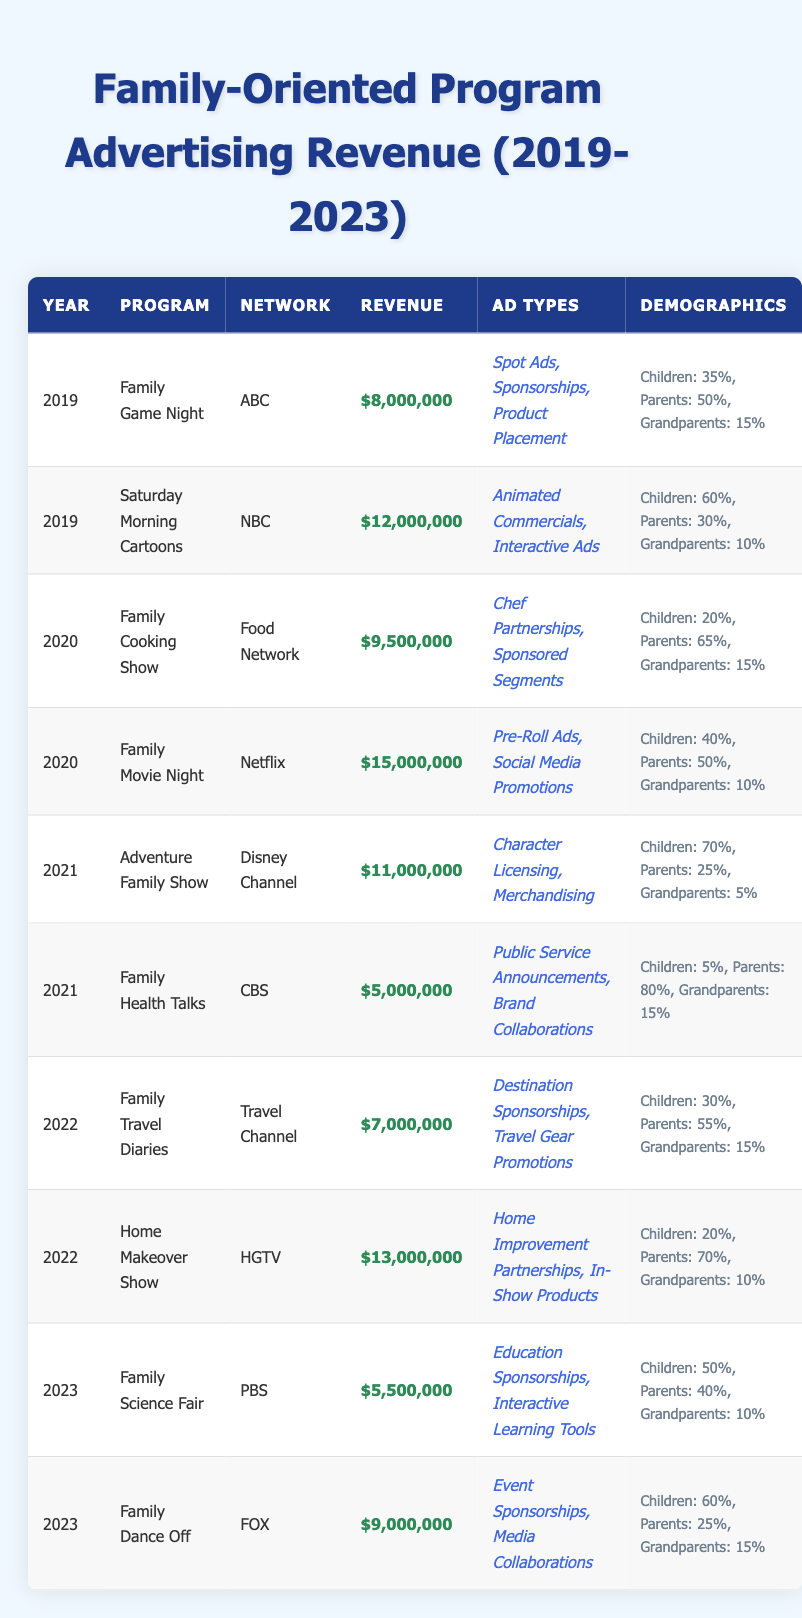What was the total advertising revenue for family-oriented programs in 2020? In 2020, the two programs listed are "Family Cooking Show" with $9,500,000 and "Family Movie Night" with $15,000,000. Summing these amounts gives $9,500,000 + $15,000,000 = $24,500,000.
Answer: $24,500,000 Which program generated the highest advertising revenue in 2021? In 2021, the two programs are "Adventure Family Show" with $11,000,000 and "Family Health Talks" with $5,000,000. The higher amount is $11,000,000 from "Adventure Family Show."
Answer: Adventure Family Show What percentage of the audience for "Family Science Fair" in 2023 were children? The demographics for "Family Science Fair" in 2023 state that 50% of the audience were children.
Answer: 50% How does the advertising revenue of "Home Makeover Show" in 2022 compare to that of "Family Dance Off" in 2023? "Home Makeover Show" earned $13,000,000 in 2022, while "Family Dance Off" earned $9,000,000 in 2023. Comparing these, $13,000,000 is greater than $9,000,000.
Answer: Home Makeover Show had higher revenue What is the total revenue across all years for programs with "Sponsorships" in their ad types? The programs with "Sponsorships" are "Family Game Night" ($8,000,000), "Family Cooking Show" ($9,500,000), "Family Science Fair" ($5,500,000), and "Family Dance Off" ($9,000,000). Summing these revenues gives $8,000,000 + $9,500,000 + $5,500,000 + $9,000,000 = $32,000,000.
Answer: $32,000,000 What percentage of the audience for "Adventure Family Show" in 2021 were grandparents? The demographics for "Adventure Family Show" indicate that 5% of the audience were grandparents.
Answer: 5% Was "Saturday Morning Cartoons" the most profitable program in 2019? In 2019, "Saturday Morning Cartoons" earned $12,000,000, while "Family Game Night" earned $8,000,000. Since $12,000,000 is greater than $8,000,000, "Saturday Morning Cartoons" was the most profitable program that year.
Answer: Yes What is the average revenue for family-oriented programs across all the years listed? The total revenue summed over all entries is ($8,000,000 + $12,000,000 + $9,500,000 + $15,000,000 + $11,000,000 + $5,000,000 + $7,000,000 + $13,000,000 + $5,500,000 + $9,000,000) = $86,500,000. There are 10 programs, so the average is $86,500,000 / 10 = $8,650,000.
Answer: $8,650,000 Which year saw the least advertising revenue for family-oriented programs? By examining the total revenues for the years, 2019 has $20,000,000 (8,000,000+12,000,000), 2020 has $24,500,000, 2021 had $16,000,000, 2022 had $20,000,000, and 2023 had $14,500,000. Since $14,500,000 is the lowest, 2023 had the least revenue.
Answer: 2023 Are "Sponsorships" more common than "Product Placement" among the ad types listed? "Sponsorships" appear in 3 programs ("Family Game Night," "Family Cooking Show," and "Family Dance Off"), while "Product Placement" is only in "Family Game Night." Since 3 is greater than 1, sponsorships are more common.
Answer: Yes What was the revenue difference between the program with the highest revenue in 2020 and the program with the lowest revenue in 2021? In 2020, "Family Movie Night" had the highest revenue of $15,000,000 and "Family Health Talks" in 2021 had the lowest revenue of $5,000,000. The difference is $15,000,000 - $5,000,000 = $10,000,000.
Answer: $10,000,000 